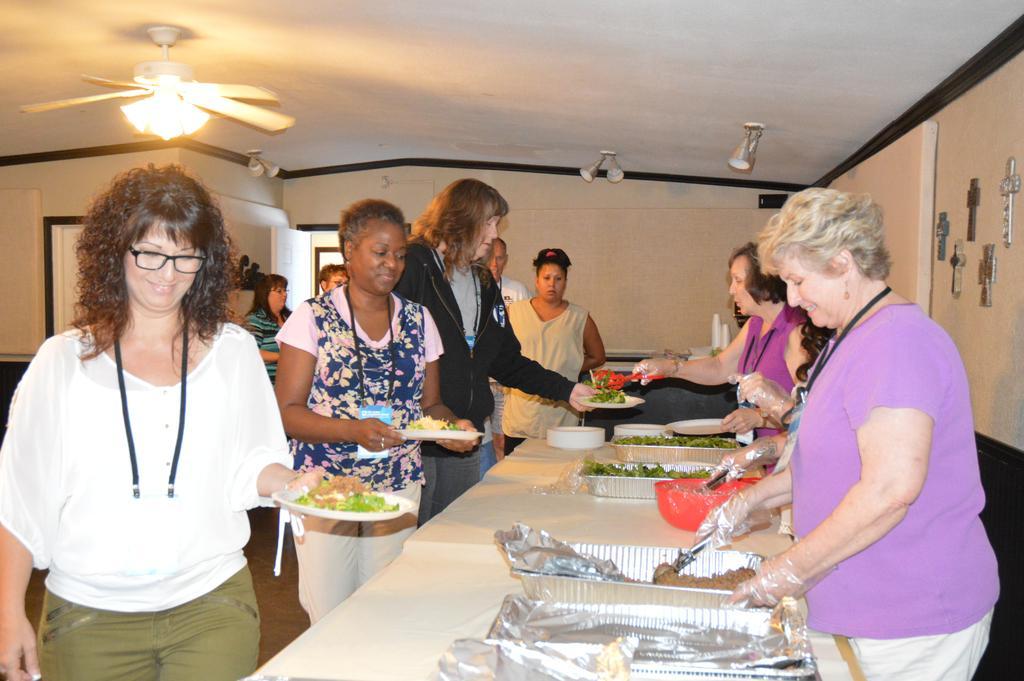Could you give a brief overview of what you see in this image? In this image we can see some group of persons standing, some are serving food and some are eating and there are some food items on the table and in the background of the image there is a wall, there are some lights, ceiling fan. 